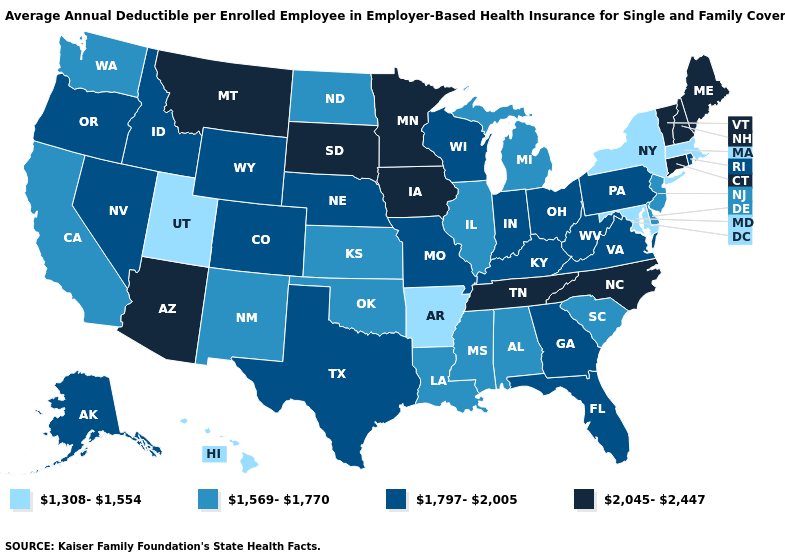What is the lowest value in states that border Michigan?
Answer briefly. 1,797-2,005. Which states have the lowest value in the South?
Answer briefly. Arkansas, Maryland. Name the states that have a value in the range 1,569-1,770?
Be succinct. Alabama, California, Delaware, Illinois, Kansas, Louisiana, Michigan, Mississippi, New Jersey, New Mexico, North Dakota, Oklahoma, South Carolina, Washington. Name the states that have a value in the range 1,308-1,554?
Quick response, please. Arkansas, Hawaii, Maryland, Massachusetts, New York, Utah. What is the highest value in the USA?
Give a very brief answer. 2,045-2,447. Name the states that have a value in the range 1,797-2,005?
Write a very short answer. Alaska, Colorado, Florida, Georgia, Idaho, Indiana, Kentucky, Missouri, Nebraska, Nevada, Ohio, Oregon, Pennsylvania, Rhode Island, Texas, Virginia, West Virginia, Wisconsin, Wyoming. What is the value of Utah?
Quick response, please. 1,308-1,554. What is the value of Minnesota?
Give a very brief answer. 2,045-2,447. Does Delaware have the highest value in the USA?
Write a very short answer. No. Name the states that have a value in the range 1,308-1,554?
Give a very brief answer. Arkansas, Hawaii, Maryland, Massachusetts, New York, Utah. Is the legend a continuous bar?
Be succinct. No. Among the states that border Montana , which have the highest value?
Short answer required. South Dakota. Name the states that have a value in the range 1,308-1,554?
Be succinct. Arkansas, Hawaii, Maryland, Massachusetts, New York, Utah. Does the first symbol in the legend represent the smallest category?
Keep it brief. Yes. What is the lowest value in states that border Georgia?
Keep it brief. 1,569-1,770. 